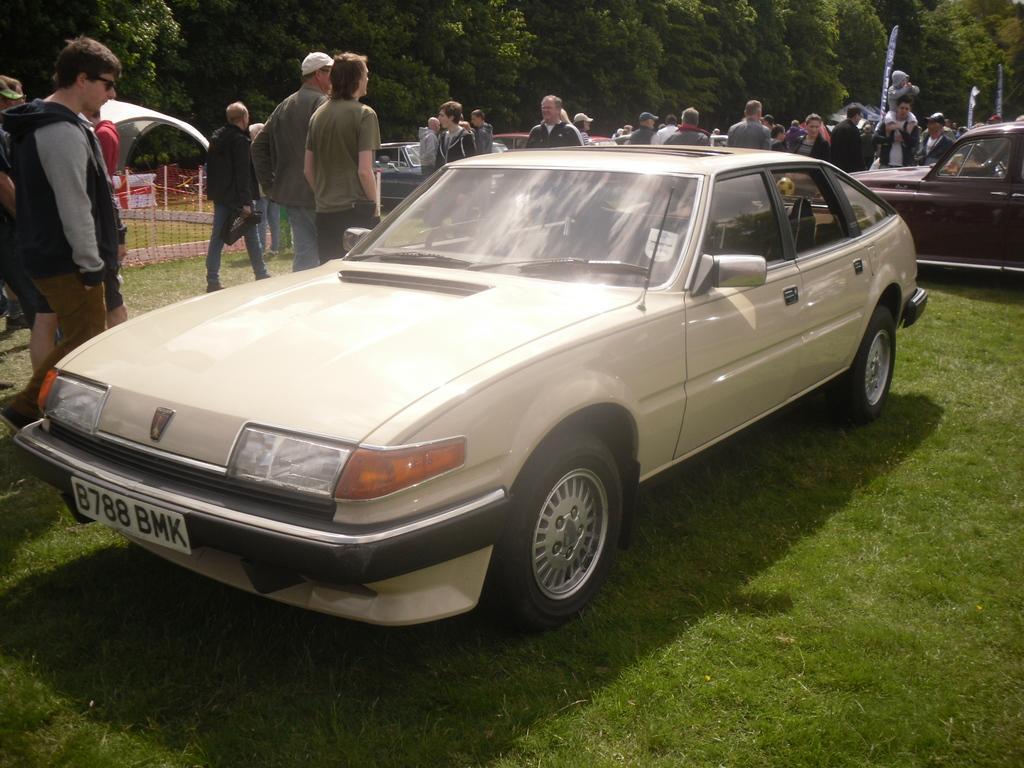Could you give a brief overview of what you see in this image? In the image I can see a place where we have some people and cars on the grass and also I can see some trees and plants. 